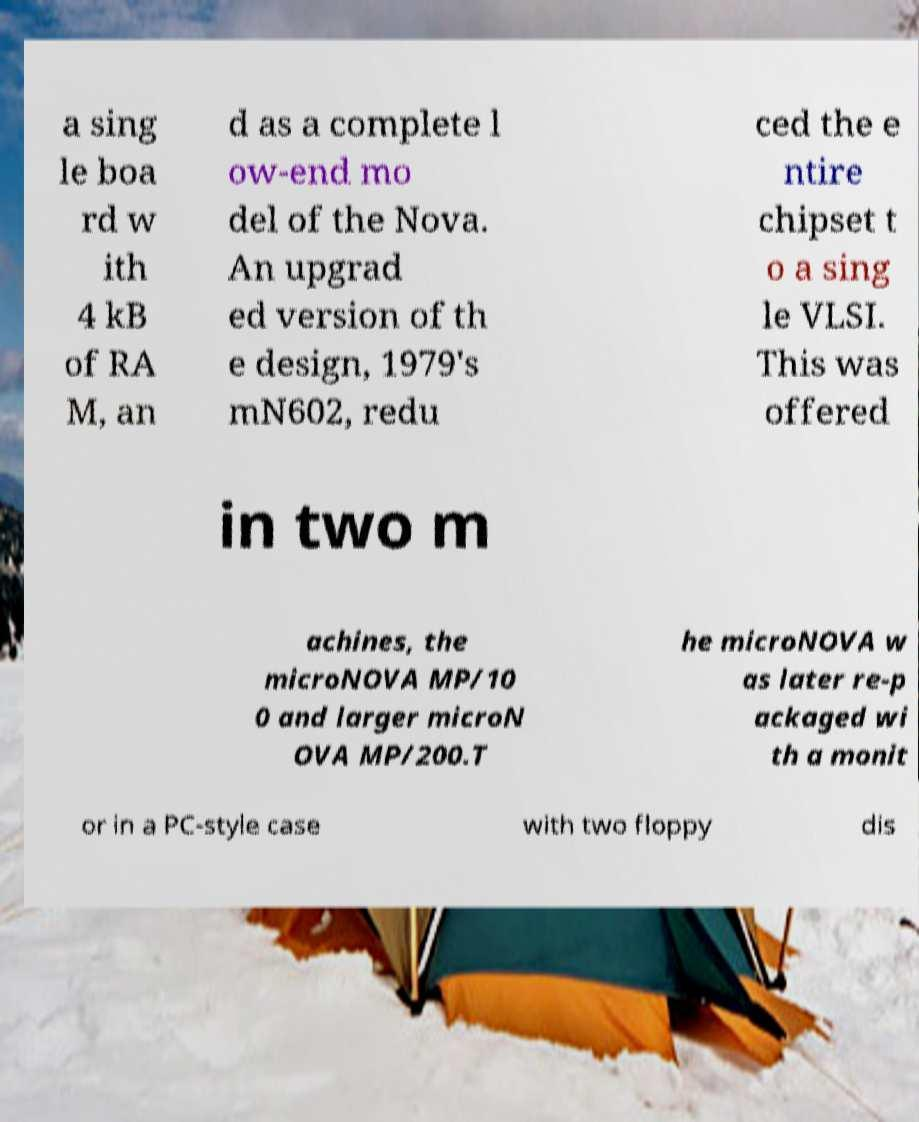Could you extract and type out the text from this image? a sing le boa rd w ith 4 kB of RA M, an d as a complete l ow-end mo del of the Nova. An upgrad ed version of th e design, 1979's mN602, redu ced the e ntire chipset t o a sing le VLSI. This was offered in two m achines, the microNOVA MP/10 0 and larger microN OVA MP/200.T he microNOVA w as later re-p ackaged wi th a monit or in a PC-style case with two floppy dis 